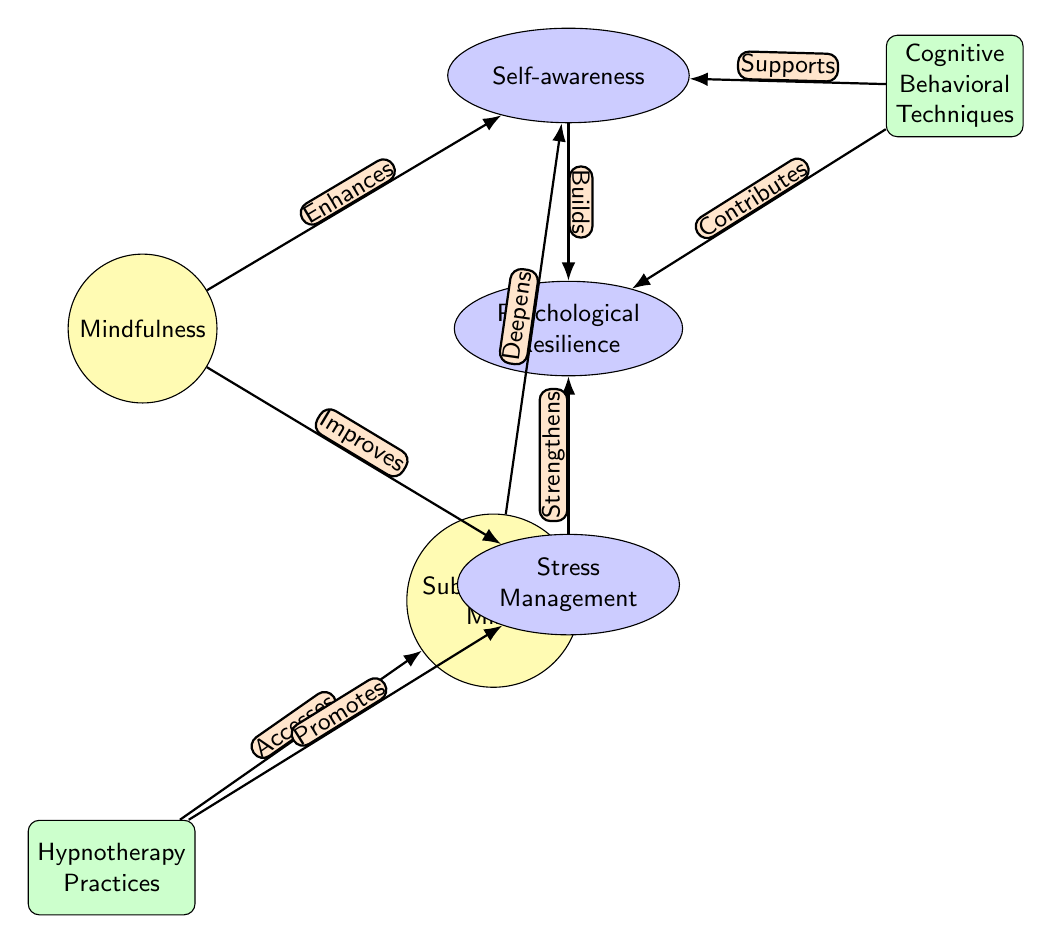What is the main concept represented at the top of the diagram? The main concept at the top is "Mindfulness," which is prominently positioned as the starting point of the relationships in the diagram.
Answer: Mindfulness How many outcomes are indicated in the diagram? There are three outcome nodes in the diagram: "Self-awareness," "Psychological Resilience," and "Stress Management," which can be counted visually.
Answer: Three What practice is linked to the subconscious mind? The practice linked to the subconscious mind is "Hypnotherapy Practices," which accesses the subconscious as depicted in the diagram.
Answer: Hypnotherapy Practices Which node does "Stress Management" strengthen? "Stress Management" strengthens "Psychological Resilience," as illustrated by the directional edge connecting these two nodes in the diagram.
Answer: Psychological Resilience How does "Cognitive Behavioral Techniques" support "Self-awareness"? "Cognitive Behavioral Techniques" supports "Self-awareness," indicated by the directional edge pointing from the cognitive practices node to the self-awareness node in the diagram.
Answer: Supports What is one way that mindfulness impacts stress? Mindfulness "Improves" stress, as evidenced by the labeled edge connecting mindfulness to the stress node, indicating a positive influence.
Answer: Improves What effect does hypnotherapy have on stress? Hypnotherapy "Promotes" stress management, shown by the edge connecting hypnotherapy practices with the stress node, indicating a supportive relationship.
Answer: Promotes Which two nodes are connected through the concept of accessing the subconscious? "Hypnotherapy Practices" accesses the "Subconscious Mind," as depicted by the edge connecting these two nodes, showing a direct relationship in the diagram.
Answer: Subconscious Mind How are "Self-awareness" and "Psychological Resilience" related? "Self-awareness" builds "Psychological Resilience," evidenced by the arrow indicating a directional relationship illustrating how self-awareness contributes to resilience.
Answer: Builds 